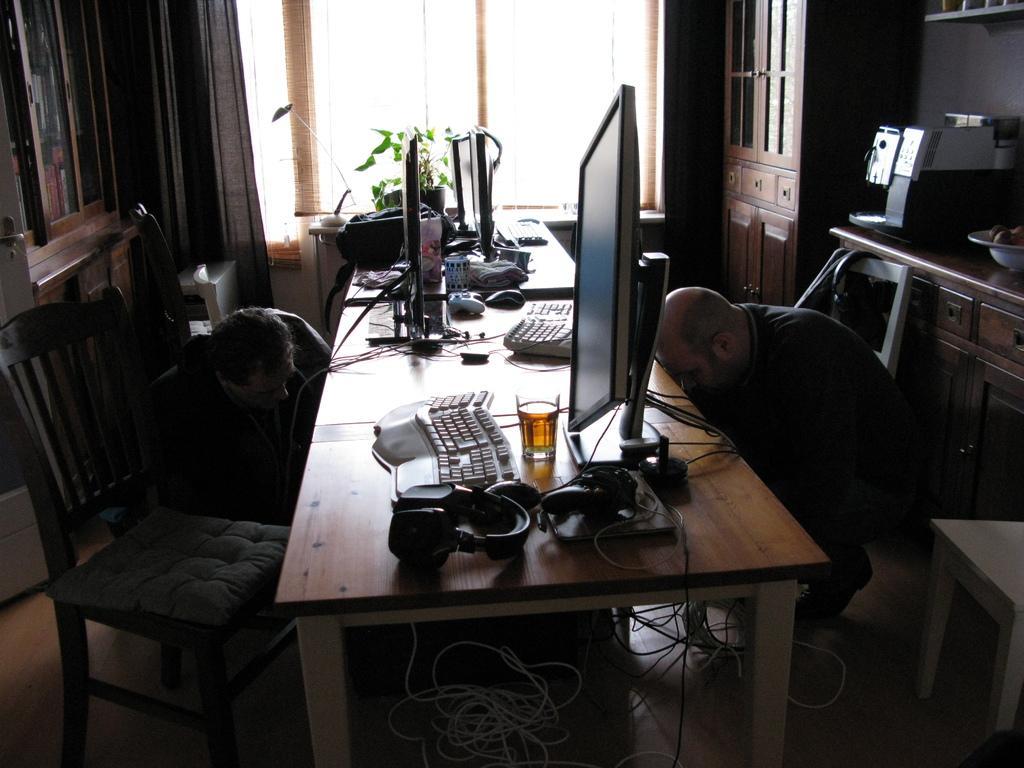How would you summarize this image in a sentence or two? In this picture we can see a table and on table we have keyboard, headsets, glass, monitor, wires and flower pot, jar and aside to this table two men are bending on their knees and we have chair and in background we can see window with curtains, cupboards, bowl, racks. 